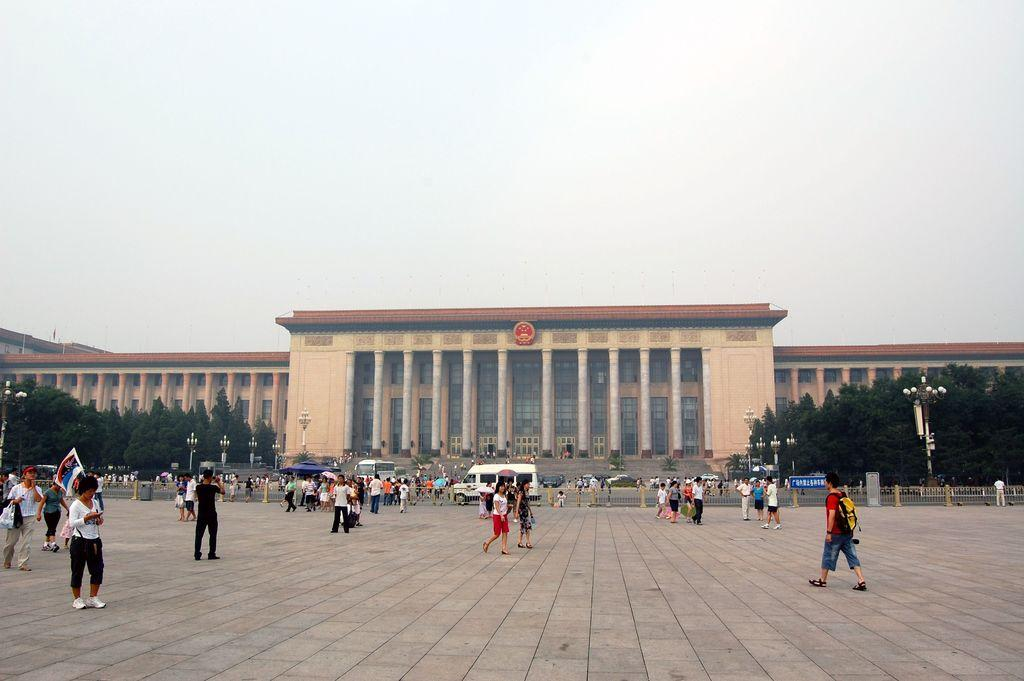What can be seen in the background of the image? There is a building and trees in the background of the image. What structures are present in the image? There are light poles in the image. What are the people in the image doing? The people are walking on the road in the image. What is visible at the top of the image? The sky is visible at the top of the image. What type of shoes can be seen on the animal in the image? There is no animal present in the image, and therefore no shoes can be seen on an animal. What is the acoustics like in the image? The provided facts do not give any information about the acoustics in the image, so it cannot be determined. 